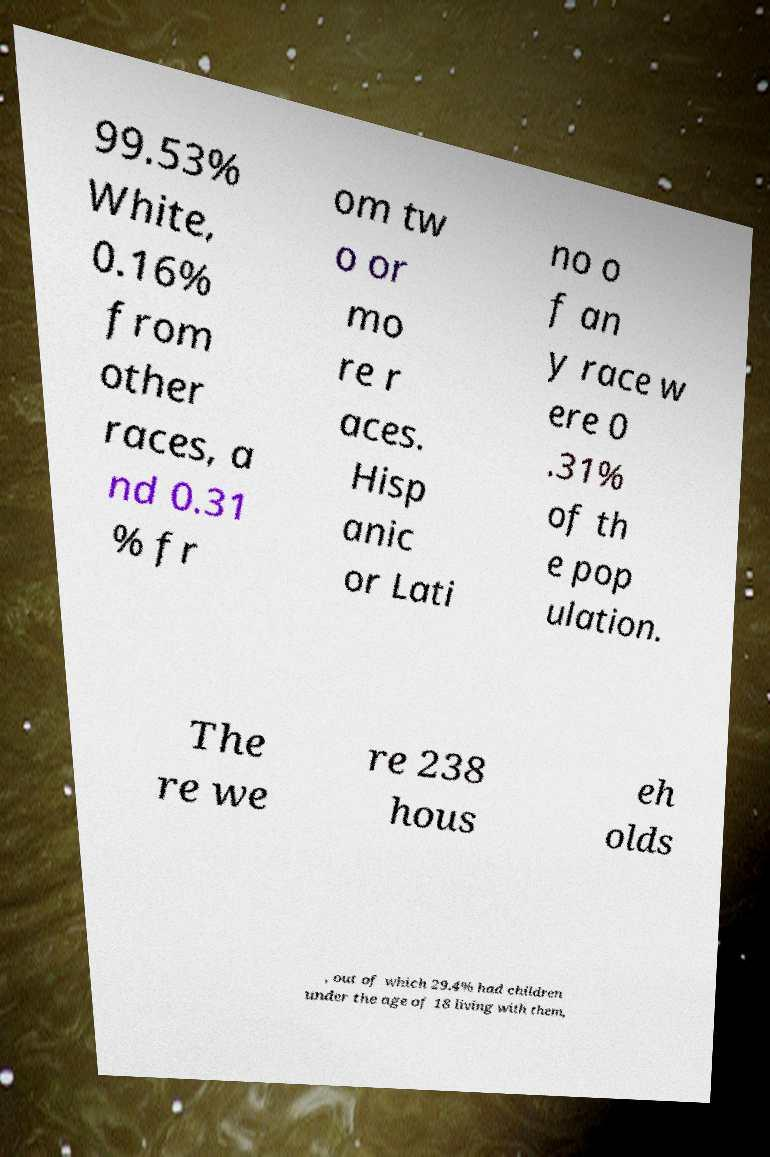Could you assist in decoding the text presented in this image and type it out clearly? 99.53% White, 0.16% from other races, a nd 0.31 % fr om tw o or mo re r aces. Hisp anic or Lati no o f an y race w ere 0 .31% of th e pop ulation. The re we re 238 hous eh olds , out of which 29.4% had children under the age of 18 living with them, 